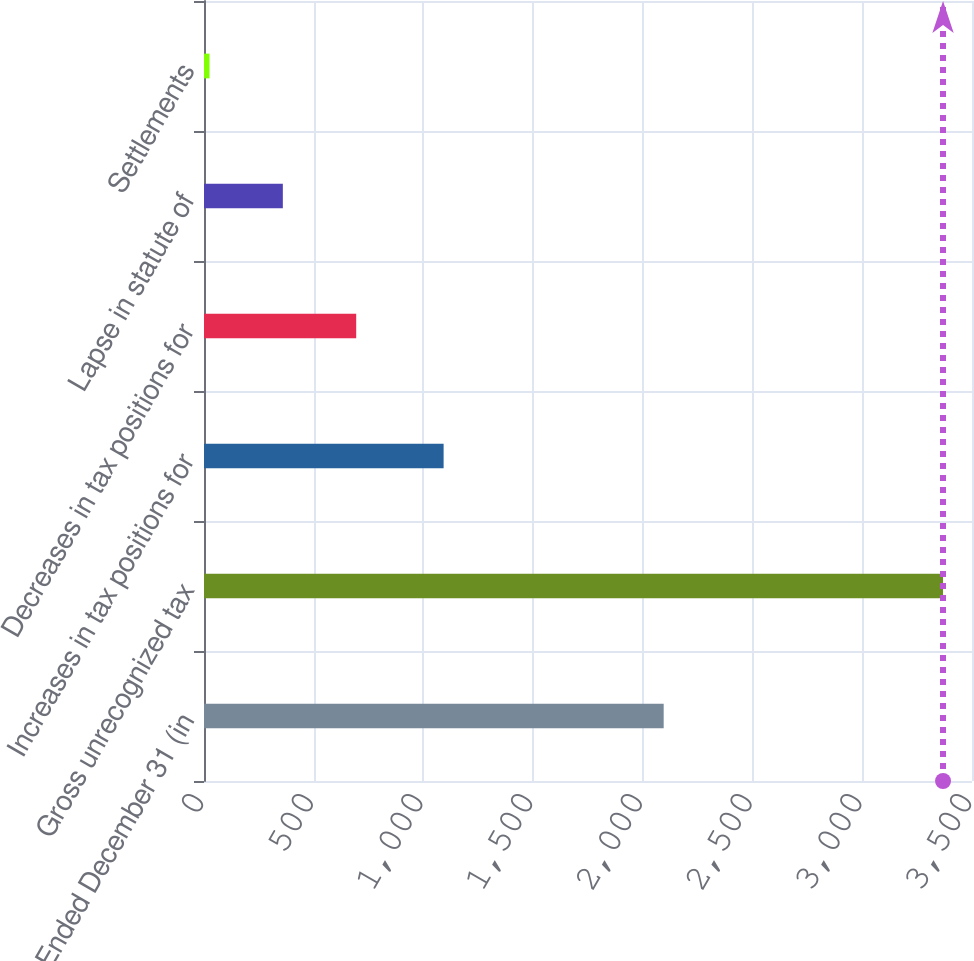<chart> <loc_0><loc_0><loc_500><loc_500><bar_chart><fcel>Year Ended December 31 (in<fcel>Gross unrecognized tax<fcel>Increases in tax positions for<fcel>Decreases in tax positions for<fcel>Lapse in statute of<fcel>Settlements<nl><fcel>2094.9<fcel>3368<fcel>1092<fcel>693.6<fcel>359.3<fcel>25<nl></chart> 